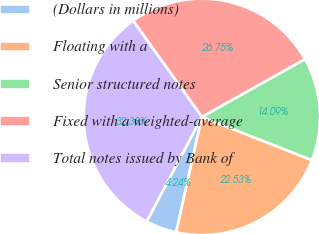<chart> <loc_0><loc_0><loc_500><loc_500><pie_chart><fcel>(Dollars in millions)<fcel>Floating with a<fcel>Senior structured notes<fcel>Fixed with a weighted-average<fcel>Total notes issued by Bank of<nl><fcel>4.24%<fcel>22.53%<fcel>14.09%<fcel>26.75%<fcel>32.38%<nl></chart> 